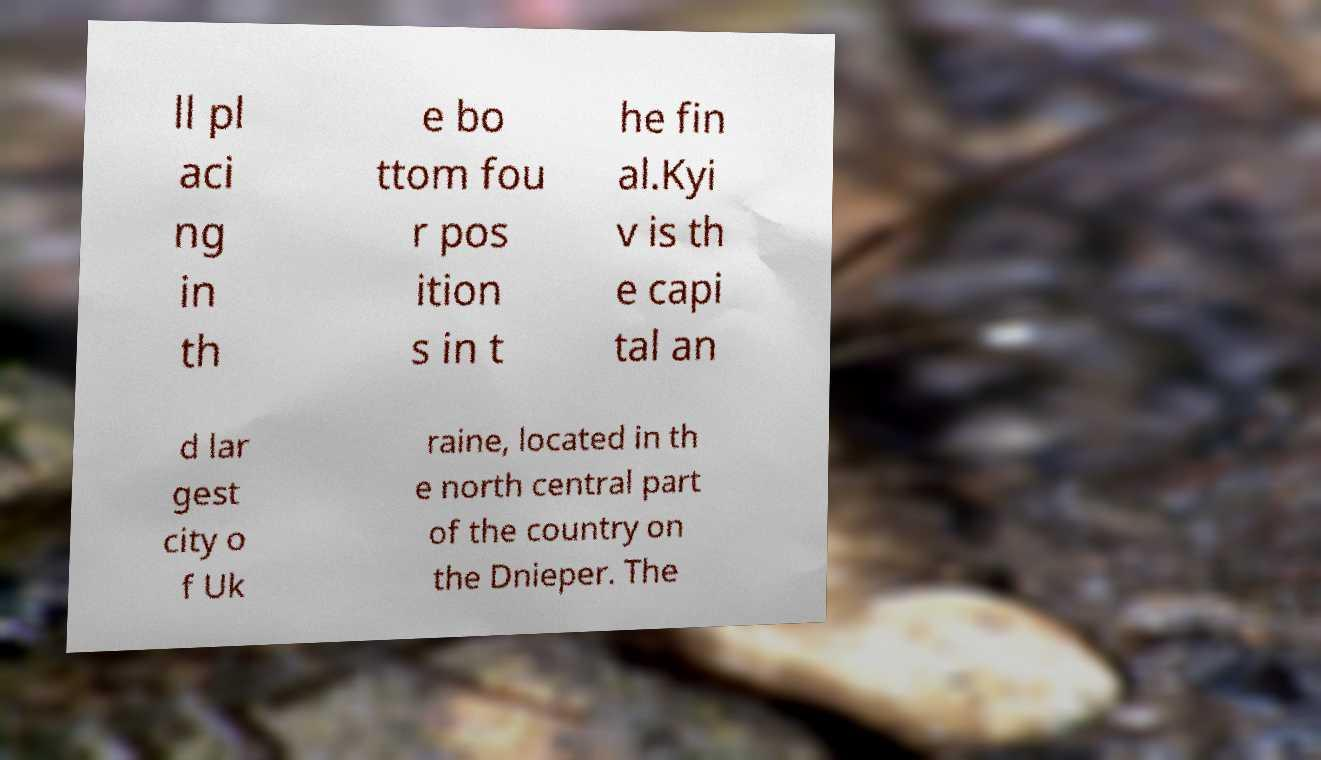Can you accurately transcribe the text from the provided image for me? ll pl aci ng in th e bo ttom fou r pos ition s in t he fin al.Kyi v is th e capi tal an d lar gest city o f Uk raine, located in th e north central part of the country on the Dnieper. The 